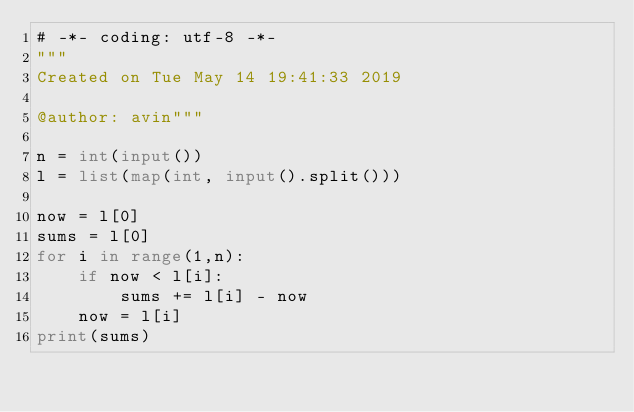Convert code to text. <code><loc_0><loc_0><loc_500><loc_500><_Python_># -*- coding: utf-8 -*-
"""
Created on Tue May 14 19:41:33 2019

@author: avin"""

n = int(input())
l = list(map(int, input().split()))

now = l[0]
sums = l[0]
for i in range(1,n):
    if now < l[i]:
        sums += l[i] - now
    now = l[i]
print(sums)</code> 